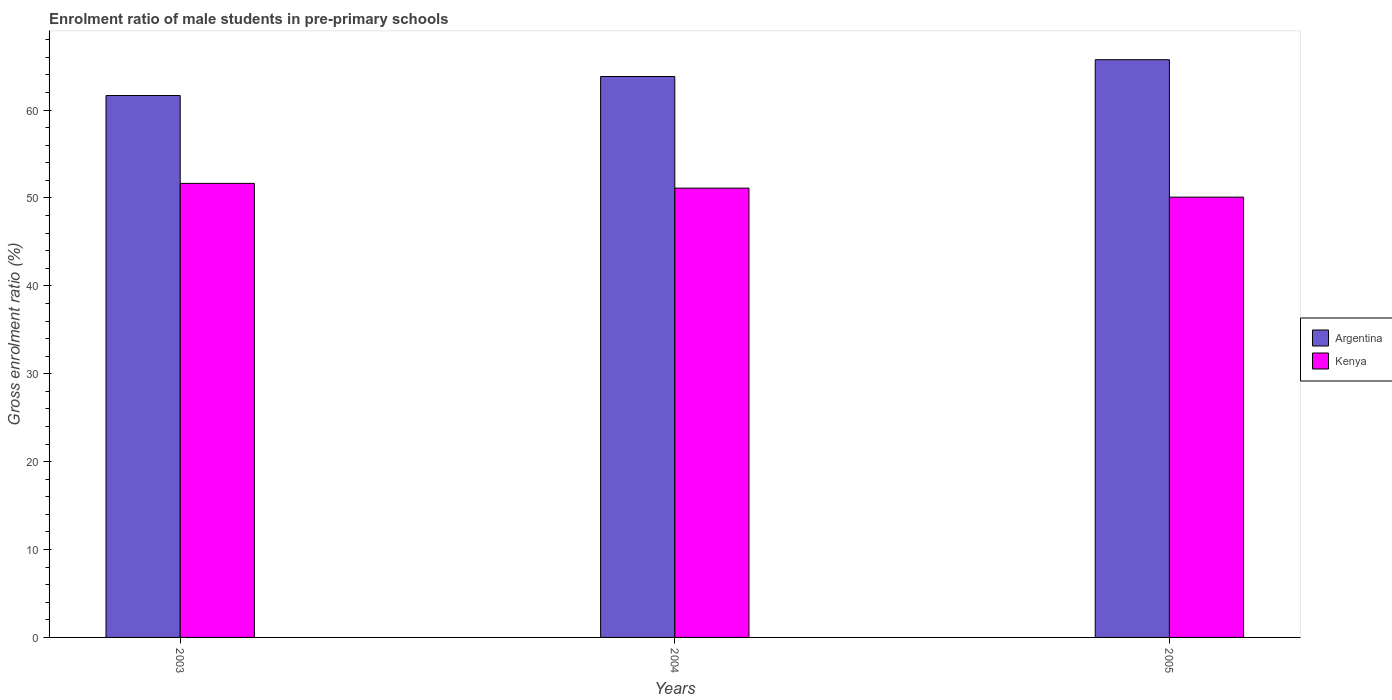Are the number of bars per tick equal to the number of legend labels?
Offer a very short reply. Yes. Are the number of bars on each tick of the X-axis equal?
Provide a short and direct response. Yes. How many bars are there on the 3rd tick from the left?
Ensure brevity in your answer.  2. What is the label of the 3rd group of bars from the left?
Your response must be concise. 2005. What is the enrolment ratio of male students in pre-primary schools in Kenya in 2003?
Keep it short and to the point. 51.66. Across all years, what is the maximum enrolment ratio of male students in pre-primary schools in Kenya?
Give a very brief answer. 51.66. Across all years, what is the minimum enrolment ratio of male students in pre-primary schools in Kenya?
Your answer should be very brief. 50.09. In which year was the enrolment ratio of male students in pre-primary schools in Kenya maximum?
Your answer should be very brief. 2003. What is the total enrolment ratio of male students in pre-primary schools in Kenya in the graph?
Offer a very short reply. 152.87. What is the difference between the enrolment ratio of male students in pre-primary schools in Argentina in 2003 and that in 2004?
Make the answer very short. -2.16. What is the difference between the enrolment ratio of male students in pre-primary schools in Kenya in 2005 and the enrolment ratio of male students in pre-primary schools in Argentina in 2004?
Your answer should be compact. -13.72. What is the average enrolment ratio of male students in pre-primary schools in Argentina per year?
Give a very brief answer. 63.73. In the year 2003, what is the difference between the enrolment ratio of male students in pre-primary schools in Kenya and enrolment ratio of male students in pre-primary schools in Argentina?
Keep it short and to the point. -10. What is the ratio of the enrolment ratio of male students in pre-primary schools in Kenya in 2003 to that in 2005?
Keep it short and to the point. 1.03. Is the difference between the enrolment ratio of male students in pre-primary schools in Kenya in 2003 and 2005 greater than the difference between the enrolment ratio of male students in pre-primary schools in Argentina in 2003 and 2005?
Make the answer very short. Yes. What is the difference between the highest and the second highest enrolment ratio of male students in pre-primary schools in Argentina?
Offer a very short reply. 1.91. What is the difference between the highest and the lowest enrolment ratio of male students in pre-primary schools in Argentina?
Your answer should be compact. 4.07. Is the sum of the enrolment ratio of male students in pre-primary schools in Kenya in 2003 and 2004 greater than the maximum enrolment ratio of male students in pre-primary schools in Argentina across all years?
Offer a very short reply. Yes. What does the 1st bar from the left in 2003 represents?
Provide a succinct answer. Argentina. Are all the bars in the graph horizontal?
Give a very brief answer. No. Does the graph contain grids?
Make the answer very short. No. How are the legend labels stacked?
Keep it short and to the point. Vertical. What is the title of the graph?
Provide a succinct answer. Enrolment ratio of male students in pre-primary schools. What is the Gross enrolment ratio (%) of Argentina in 2003?
Provide a short and direct response. 61.66. What is the Gross enrolment ratio (%) in Kenya in 2003?
Ensure brevity in your answer.  51.66. What is the Gross enrolment ratio (%) of Argentina in 2004?
Provide a short and direct response. 63.82. What is the Gross enrolment ratio (%) in Kenya in 2004?
Offer a terse response. 51.12. What is the Gross enrolment ratio (%) in Argentina in 2005?
Keep it short and to the point. 65.73. What is the Gross enrolment ratio (%) in Kenya in 2005?
Offer a terse response. 50.09. Across all years, what is the maximum Gross enrolment ratio (%) of Argentina?
Make the answer very short. 65.73. Across all years, what is the maximum Gross enrolment ratio (%) in Kenya?
Your response must be concise. 51.66. Across all years, what is the minimum Gross enrolment ratio (%) of Argentina?
Provide a short and direct response. 61.66. Across all years, what is the minimum Gross enrolment ratio (%) of Kenya?
Offer a very short reply. 50.09. What is the total Gross enrolment ratio (%) in Argentina in the graph?
Provide a short and direct response. 191.2. What is the total Gross enrolment ratio (%) in Kenya in the graph?
Provide a short and direct response. 152.87. What is the difference between the Gross enrolment ratio (%) of Argentina in 2003 and that in 2004?
Your response must be concise. -2.16. What is the difference between the Gross enrolment ratio (%) of Kenya in 2003 and that in 2004?
Ensure brevity in your answer.  0.54. What is the difference between the Gross enrolment ratio (%) in Argentina in 2003 and that in 2005?
Make the answer very short. -4.07. What is the difference between the Gross enrolment ratio (%) in Kenya in 2003 and that in 2005?
Make the answer very short. 1.57. What is the difference between the Gross enrolment ratio (%) in Argentina in 2004 and that in 2005?
Make the answer very short. -1.91. What is the difference between the Gross enrolment ratio (%) of Argentina in 2003 and the Gross enrolment ratio (%) of Kenya in 2004?
Offer a very short reply. 10.54. What is the difference between the Gross enrolment ratio (%) of Argentina in 2003 and the Gross enrolment ratio (%) of Kenya in 2005?
Give a very brief answer. 11.56. What is the difference between the Gross enrolment ratio (%) of Argentina in 2004 and the Gross enrolment ratio (%) of Kenya in 2005?
Your response must be concise. 13.72. What is the average Gross enrolment ratio (%) in Argentina per year?
Offer a terse response. 63.73. What is the average Gross enrolment ratio (%) in Kenya per year?
Your answer should be compact. 50.96. In the year 2003, what is the difference between the Gross enrolment ratio (%) of Argentina and Gross enrolment ratio (%) of Kenya?
Give a very brief answer. 10. In the year 2004, what is the difference between the Gross enrolment ratio (%) of Argentina and Gross enrolment ratio (%) of Kenya?
Provide a succinct answer. 12.7. In the year 2005, what is the difference between the Gross enrolment ratio (%) of Argentina and Gross enrolment ratio (%) of Kenya?
Offer a very short reply. 15.64. What is the ratio of the Gross enrolment ratio (%) of Argentina in 2003 to that in 2004?
Your answer should be compact. 0.97. What is the ratio of the Gross enrolment ratio (%) of Kenya in 2003 to that in 2004?
Keep it short and to the point. 1.01. What is the ratio of the Gross enrolment ratio (%) of Argentina in 2003 to that in 2005?
Your answer should be very brief. 0.94. What is the ratio of the Gross enrolment ratio (%) in Kenya in 2003 to that in 2005?
Give a very brief answer. 1.03. What is the ratio of the Gross enrolment ratio (%) in Argentina in 2004 to that in 2005?
Ensure brevity in your answer.  0.97. What is the ratio of the Gross enrolment ratio (%) in Kenya in 2004 to that in 2005?
Provide a succinct answer. 1.02. What is the difference between the highest and the second highest Gross enrolment ratio (%) in Argentina?
Offer a very short reply. 1.91. What is the difference between the highest and the second highest Gross enrolment ratio (%) in Kenya?
Offer a very short reply. 0.54. What is the difference between the highest and the lowest Gross enrolment ratio (%) of Argentina?
Your answer should be very brief. 4.07. What is the difference between the highest and the lowest Gross enrolment ratio (%) in Kenya?
Your answer should be compact. 1.57. 